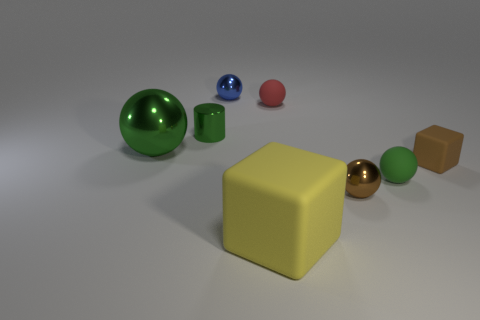There is a metal sphere that is the same color as the tiny cylinder; what is its size?
Keep it short and to the point. Large. What is the shape of the green metallic object behind the big green metal sphere?
Keep it short and to the point. Cylinder. There is a green sphere left of the small brown thing in front of the tiny matte sphere that is in front of the red matte sphere; what is its material?
Your answer should be very brief. Metal. How many other things are the same size as the blue metal ball?
Your answer should be compact. 5. There is another blue object that is the same shape as the big metal object; what material is it?
Offer a very short reply. Metal. The small cube is what color?
Your response must be concise. Brown. There is a shiny sphere that is behind the green ball that is left of the yellow matte thing; what is its color?
Make the answer very short. Blue. There is a large rubber thing; does it have the same color as the small rubber ball that is behind the small brown cube?
Your answer should be very brief. No. What number of large matte objects are behind the brown object that is to the right of the tiny green thing that is on the right side of the blue metallic sphere?
Your answer should be very brief. 0. Are there any blue shiny objects in front of the big yellow block?
Keep it short and to the point. No. 